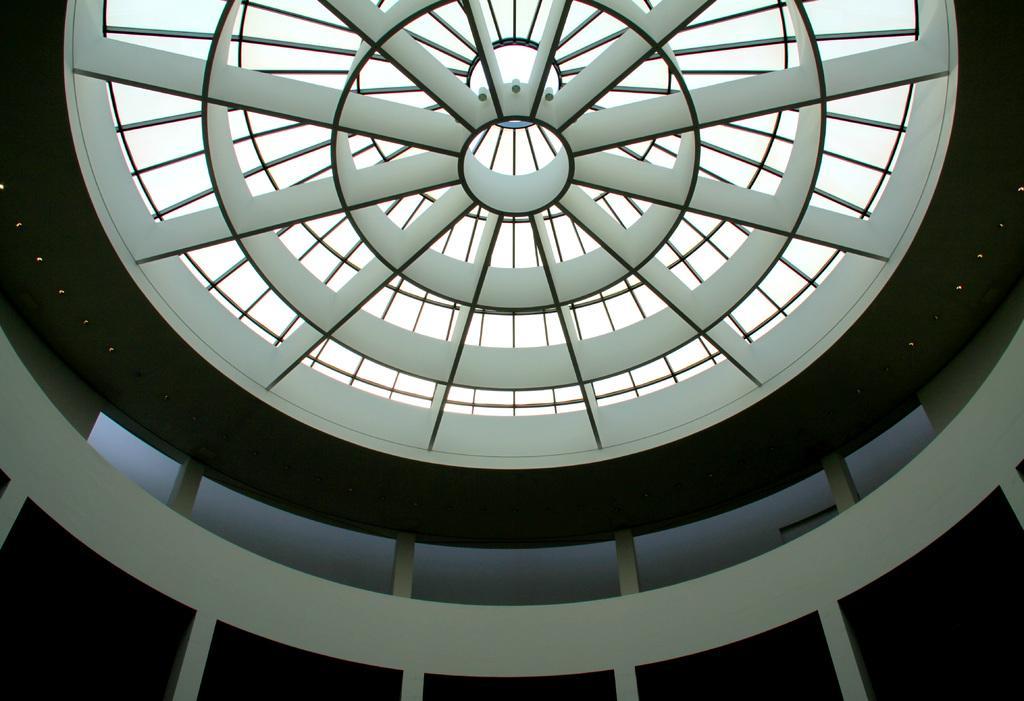How would you summarize this image in a sentence or two? In the image there is a ceiling of a room with a round shape designs on it. And also there are lights. Also there are pillars and walls. 